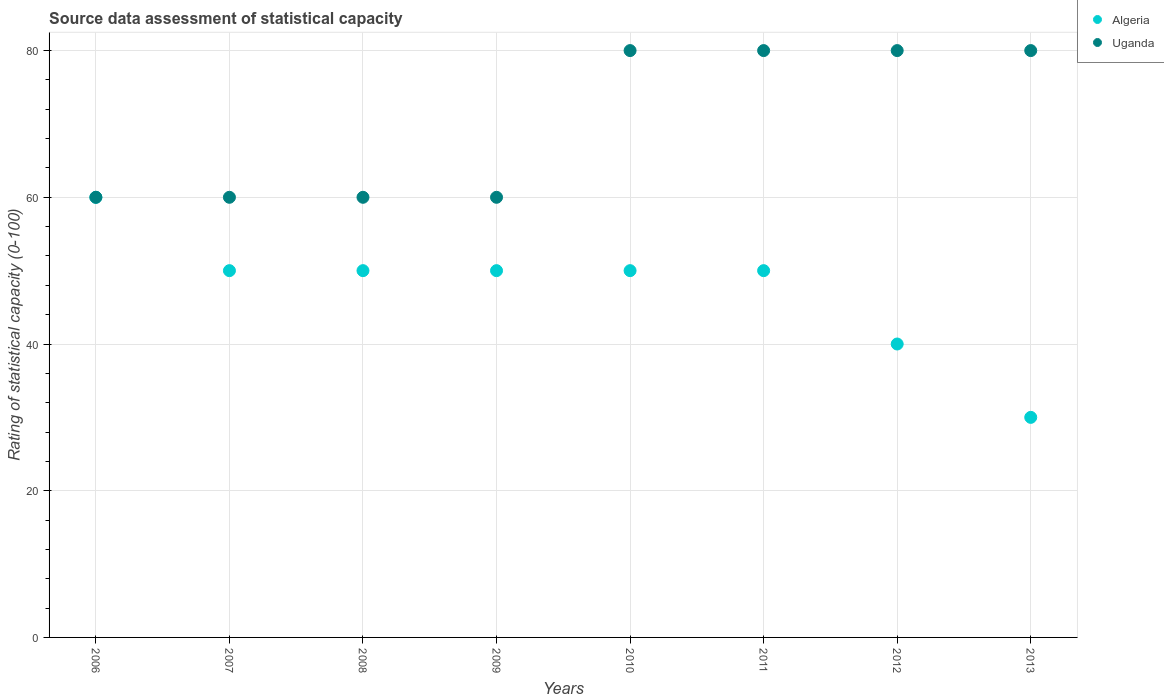Is the number of dotlines equal to the number of legend labels?
Make the answer very short. Yes. What is the rating of statistical capacity in Uganda in 2013?
Your answer should be compact. 80. Across all years, what is the maximum rating of statistical capacity in Algeria?
Ensure brevity in your answer.  60. Across all years, what is the minimum rating of statistical capacity in Algeria?
Offer a terse response. 30. In which year was the rating of statistical capacity in Uganda maximum?
Give a very brief answer. 2010. In which year was the rating of statistical capacity in Uganda minimum?
Your response must be concise. 2006. What is the total rating of statistical capacity in Algeria in the graph?
Offer a terse response. 380. What is the difference between the rating of statistical capacity in Algeria in 2006 and that in 2013?
Offer a terse response. 30. What is the difference between the rating of statistical capacity in Uganda in 2012 and the rating of statistical capacity in Algeria in 2010?
Make the answer very short. 30. What is the average rating of statistical capacity in Uganda per year?
Offer a terse response. 70. In the year 2007, what is the difference between the rating of statistical capacity in Uganda and rating of statistical capacity in Algeria?
Your response must be concise. 10. What is the ratio of the rating of statistical capacity in Algeria in 2007 to that in 2011?
Your answer should be compact. 1. Is the difference between the rating of statistical capacity in Uganda in 2006 and 2010 greater than the difference between the rating of statistical capacity in Algeria in 2006 and 2010?
Your response must be concise. No. What is the difference between the highest and the second highest rating of statistical capacity in Uganda?
Keep it short and to the point. 0. What is the difference between the highest and the lowest rating of statistical capacity in Uganda?
Provide a short and direct response. 20. In how many years, is the rating of statistical capacity in Uganda greater than the average rating of statistical capacity in Uganda taken over all years?
Make the answer very short. 4. Is the sum of the rating of statistical capacity in Algeria in 2010 and 2011 greater than the maximum rating of statistical capacity in Uganda across all years?
Provide a succinct answer. Yes. Is the rating of statistical capacity in Algeria strictly less than the rating of statistical capacity in Uganda over the years?
Your answer should be very brief. No. How many years are there in the graph?
Your response must be concise. 8. Are the values on the major ticks of Y-axis written in scientific E-notation?
Give a very brief answer. No. Does the graph contain any zero values?
Your response must be concise. No. Does the graph contain grids?
Give a very brief answer. Yes. How many legend labels are there?
Offer a terse response. 2. How are the legend labels stacked?
Make the answer very short. Vertical. What is the title of the graph?
Offer a terse response. Source data assessment of statistical capacity. Does "Pakistan" appear as one of the legend labels in the graph?
Offer a very short reply. No. What is the label or title of the Y-axis?
Ensure brevity in your answer.  Rating of statistical capacity (0-100). What is the Rating of statistical capacity (0-100) of Algeria in 2006?
Keep it short and to the point. 60. What is the Rating of statistical capacity (0-100) of Uganda in 2007?
Offer a terse response. 60. What is the Rating of statistical capacity (0-100) of Uganda in 2008?
Your answer should be compact. 60. What is the Rating of statistical capacity (0-100) of Algeria in 2009?
Your answer should be very brief. 50. What is the Rating of statistical capacity (0-100) in Uganda in 2009?
Provide a succinct answer. 60. What is the Rating of statistical capacity (0-100) in Algeria in 2010?
Provide a succinct answer. 50. What is the Rating of statistical capacity (0-100) of Uganda in 2010?
Offer a very short reply. 80. What is the Rating of statistical capacity (0-100) of Algeria in 2012?
Your answer should be very brief. 40. What is the Rating of statistical capacity (0-100) in Algeria in 2013?
Provide a succinct answer. 30. Across all years, what is the maximum Rating of statistical capacity (0-100) of Uganda?
Ensure brevity in your answer.  80. Across all years, what is the minimum Rating of statistical capacity (0-100) in Algeria?
Offer a terse response. 30. What is the total Rating of statistical capacity (0-100) in Algeria in the graph?
Your answer should be very brief. 380. What is the total Rating of statistical capacity (0-100) of Uganda in the graph?
Provide a short and direct response. 560. What is the difference between the Rating of statistical capacity (0-100) in Uganda in 2006 and that in 2008?
Keep it short and to the point. 0. What is the difference between the Rating of statistical capacity (0-100) in Algeria in 2006 and that in 2009?
Your response must be concise. 10. What is the difference between the Rating of statistical capacity (0-100) in Uganda in 2006 and that in 2009?
Provide a short and direct response. 0. What is the difference between the Rating of statistical capacity (0-100) in Algeria in 2006 and that in 2010?
Offer a terse response. 10. What is the difference between the Rating of statistical capacity (0-100) of Algeria in 2006 and that in 2011?
Your response must be concise. 10. What is the difference between the Rating of statistical capacity (0-100) of Uganda in 2006 and that in 2011?
Offer a very short reply. -20. What is the difference between the Rating of statistical capacity (0-100) in Algeria in 2006 and that in 2012?
Keep it short and to the point. 20. What is the difference between the Rating of statistical capacity (0-100) of Uganda in 2006 and that in 2012?
Offer a very short reply. -20. What is the difference between the Rating of statistical capacity (0-100) of Algeria in 2006 and that in 2013?
Give a very brief answer. 30. What is the difference between the Rating of statistical capacity (0-100) of Uganda in 2006 and that in 2013?
Your answer should be compact. -20. What is the difference between the Rating of statistical capacity (0-100) of Algeria in 2007 and that in 2008?
Provide a succinct answer. 0. What is the difference between the Rating of statistical capacity (0-100) in Uganda in 2007 and that in 2009?
Offer a terse response. 0. What is the difference between the Rating of statistical capacity (0-100) of Uganda in 2007 and that in 2010?
Give a very brief answer. -20. What is the difference between the Rating of statistical capacity (0-100) in Algeria in 2007 and that in 2011?
Your answer should be very brief. 0. What is the difference between the Rating of statistical capacity (0-100) in Uganda in 2007 and that in 2011?
Your answer should be very brief. -20. What is the difference between the Rating of statistical capacity (0-100) in Algeria in 2007 and that in 2012?
Keep it short and to the point. 10. What is the difference between the Rating of statistical capacity (0-100) in Algeria in 2007 and that in 2013?
Give a very brief answer. 20. What is the difference between the Rating of statistical capacity (0-100) in Uganda in 2007 and that in 2013?
Provide a short and direct response. -20. What is the difference between the Rating of statistical capacity (0-100) of Algeria in 2008 and that in 2012?
Keep it short and to the point. 10. What is the difference between the Rating of statistical capacity (0-100) in Uganda in 2008 and that in 2012?
Offer a very short reply. -20. What is the difference between the Rating of statistical capacity (0-100) in Uganda in 2008 and that in 2013?
Your answer should be very brief. -20. What is the difference between the Rating of statistical capacity (0-100) of Uganda in 2009 and that in 2010?
Provide a short and direct response. -20. What is the difference between the Rating of statistical capacity (0-100) in Algeria in 2009 and that in 2011?
Make the answer very short. 0. What is the difference between the Rating of statistical capacity (0-100) of Uganda in 2009 and that in 2011?
Offer a terse response. -20. What is the difference between the Rating of statistical capacity (0-100) in Uganda in 2009 and that in 2012?
Keep it short and to the point. -20. What is the difference between the Rating of statistical capacity (0-100) of Algeria in 2009 and that in 2013?
Provide a succinct answer. 20. What is the difference between the Rating of statistical capacity (0-100) of Uganda in 2009 and that in 2013?
Your answer should be compact. -20. What is the difference between the Rating of statistical capacity (0-100) in Algeria in 2010 and that in 2011?
Offer a terse response. 0. What is the difference between the Rating of statistical capacity (0-100) in Uganda in 2010 and that in 2011?
Offer a very short reply. 0. What is the difference between the Rating of statistical capacity (0-100) of Algeria in 2010 and that in 2012?
Your answer should be compact. 10. What is the difference between the Rating of statistical capacity (0-100) of Uganda in 2010 and that in 2012?
Provide a succinct answer. 0. What is the difference between the Rating of statistical capacity (0-100) in Algeria in 2010 and that in 2013?
Provide a succinct answer. 20. What is the difference between the Rating of statistical capacity (0-100) in Uganda in 2010 and that in 2013?
Make the answer very short. 0. What is the difference between the Rating of statistical capacity (0-100) of Uganda in 2011 and that in 2012?
Provide a succinct answer. 0. What is the difference between the Rating of statistical capacity (0-100) of Algeria in 2011 and that in 2013?
Offer a very short reply. 20. What is the difference between the Rating of statistical capacity (0-100) in Uganda in 2011 and that in 2013?
Provide a succinct answer. 0. What is the difference between the Rating of statistical capacity (0-100) in Algeria in 2006 and the Rating of statistical capacity (0-100) in Uganda in 2007?
Your response must be concise. 0. What is the difference between the Rating of statistical capacity (0-100) in Algeria in 2006 and the Rating of statistical capacity (0-100) in Uganda in 2010?
Your answer should be compact. -20. What is the difference between the Rating of statistical capacity (0-100) in Algeria in 2006 and the Rating of statistical capacity (0-100) in Uganda in 2012?
Ensure brevity in your answer.  -20. What is the difference between the Rating of statistical capacity (0-100) in Algeria in 2006 and the Rating of statistical capacity (0-100) in Uganda in 2013?
Your response must be concise. -20. What is the difference between the Rating of statistical capacity (0-100) of Algeria in 2007 and the Rating of statistical capacity (0-100) of Uganda in 2009?
Keep it short and to the point. -10. What is the difference between the Rating of statistical capacity (0-100) of Algeria in 2007 and the Rating of statistical capacity (0-100) of Uganda in 2011?
Make the answer very short. -30. What is the difference between the Rating of statistical capacity (0-100) in Algeria in 2008 and the Rating of statistical capacity (0-100) in Uganda in 2010?
Provide a short and direct response. -30. What is the difference between the Rating of statistical capacity (0-100) in Algeria in 2008 and the Rating of statistical capacity (0-100) in Uganda in 2013?
Keep it short and to the point. -30. What is the difference between the Rating of statistical capacity (0-100) of Algeria in 2009 and the Rating of statistical capacity (0-100) of Uganda in 2011?
Keep it short and to the point. -30. What is the difference between the Rating of statistical capacity (0-100) in Algeria in 2009 and the Rating of statistical capacity (0-100) in Uganda in 2013?
Your response must be concise. -30. What is the difference between the Rating of statistical capacity (0-100) of Algeria in 2010 and the Rating of statistical capacity (0-100) of Uganda in 2011?
Offer a very short reply. -30. What is the difference between the Rating of statistical capacity (0-100) in Algeria in 2011 and the Rating of statistical capacity (0-100) in Uganda in 2013?
Provide a short and direct response. -30. What is the difference between the Rating of statistical capacity (0-100) in Algeria in 2012 and the Rating of statistical capacity (0-100) in Uganda in 2013?
Offer a terse response. -40. What is the average Rating of statistical capacity (0-100) in Algeria per year?
Provide a succinct answer. 47.5. In the year 2007, what is the difference between the Rating of statistical capacity (0-100) in Algeria and Rating of statistical capacity (0-100) in Uganda?
Offer a terse response. -10. In the year 2010, what is the difference between the Rating of statistical capacity (0-100) of Algeria and Rating of statistical capacity (0-100) of Uganda?
Your response must be concise. -30. In the year 2011, what is the difference between the Rating of statistical capacity (0-100) of Algeria and Rating of statistical capacity (0-100) of Uganda?
Offer a very short reply. -30. In the year 2013, what is the difference between the Rating of statistical capacity (0-100) in Algeria and Rating of statistical capacity (0-100) in Uganda?
Make the answer very short. -50. What is the ratio of the Rating of statistical capacity (0-100) of Algeria in 2006 to that in 2007?
Ensure brevity in your answer.  1.2. What is the ratio of the Rating of statistical capacity (0-100) in Uganda in 2006 to that in 2007?
Provide a short and direct response. 1. What is the ratio of the Rating of statistical capacity (0-100) of Algeria in 2006 to that in 2008?
Your response must be concise. 1.2. What is the ratio of the Rating of statistical capacity (0-100) of Uganda in 2006 to that in 2008?
Keep it short and to the point. 1. What is the ratio of the Rating of statistical capacity (0-100) of Uganda in 2006 to that in 2009?
Your response must be concise. 1. What is the ratio of the Rating of statistical capacity (0-100) in Uganda in 2006 to that in 2010?
Provide a short and direct response. 0.75. What is the ratio of the Rating of statistical capacity (0-100) in Algeria in 2006 to that in 2011?
Your response must be concise. 1.2. What is the ratio of the Rating of statistical capacity (0-100) of Algeria in 2006 to that in 2012?
Ensure brevity in your answer.  1.5. What is the ratio of the Rating of statistical capacity (0-100) in Uganda in 2006 to that in 2013?
Make the answer very short. 0.75. What is the ratio of the Rating of statistical capacity (0-100) of Algeria in 2007 to that in 2008?
Offer a very short reply. 1. What is the ratio of the Rating of statistical capacity (0-100) of Uganda in 2007 to that in 2010?
Provide a short and direct response. 0.75. What is the ratio of the Rating of statistical capacity (0-100) in Uganda in 2007 to that in 2011?
Provide a succinct answer. 0.75. What is the ratio of the Rating of statistical capacity (0-100) in Algeria in 2007 to that in 2013?
Give a very brief answer. 1.67. What is the ratio of the Rating of statistical capacity (0-100) of Algeria in 2008 to that in 2009?
Ensure brevity in your answer.  1. What is the ratio of the Rating of statistical capacity (0-100) in Uganda in 2008 to that in 2009?
Provide a short and direct response. 1. What is the ratio of the Rating of statistical capacity (0-100) in Uganda in 2008 to that in 2010?
Offer a terse response. 0.75. What is the ratio of the Rating of statistical capacity (0-100) in Algeria in 2008 to that in 2011?
Provide a short and direct response. 1. What is the ratio of the Rating of statistical capacity (0-100) of Uganda in 2008 to that in 2013?
Make the answer very short. 0.75. What is the ratio of the Rating of statistical capacity (0-100) of Algeria in 2009 to that in 2010?
Keep it short and to the point. 1. What is the ratio of the Rating of statistical capacity (0-100) in Algeria in 2009 to that in 2011?
Ensure brevity in your answer.  1. What is the ratio of the Rating of statistical capacity (0-100) of Algeria in 2009 to that in 2012?
Your answer should be very brief. 1.25. What is the ratio of the Rating of statistical capacity (0-100) in Algeria in 2009 to that in 2013?
Give a very brief answer. 1.67. What is the ratio of the Rating of statistical capacity (0-100) in Uganda in 2009 to that in 2013?
Offer a very short reply. 0.75. What is the ratio of the Rating of statistical capacity (0-100) in Uganda in 2010 to that in 2011?
Your response must be concise. 1. What is the ratio of the Rating of statistical capacity (0-100) of Algeria in 2010 to that in 2012?
Offer a very short reply. 1.25. What is the ratio of the Rating of statistical capacity (0-100) in Uganda in 2010 to that in 2012?
Make the answer very short. 1. What is the ratio of the Rating of statistical capacity (0-100) in Algeria in 2010 to that in 2013?
Offer a very short reply. 1.67. What is the ratio of the Rating of statistical capacity (0-100) of Uganda in 2010 to that in 2013?
Your answer should be very brief. 1. What is the ratio of the Rating of statistical capacity (0-100) in Uganda in 2011 to that in 2012?
Make the answer very short. 1. What is the ratio of the Rating of statistical capacity (0-100) in Uganda in 2011 to that in 2013?
Provide a succinct answer. 1. What is the ratio of the Rating of statistical capacity (0-100) in Algeria in 2012 to that in 2013?
Your answer should be very brief. 1.33. What is the ratio of the Rating of statistical capacity (0-100) of Uganda in 2012 to that in 2013?
Give a very brief answer. 1. 